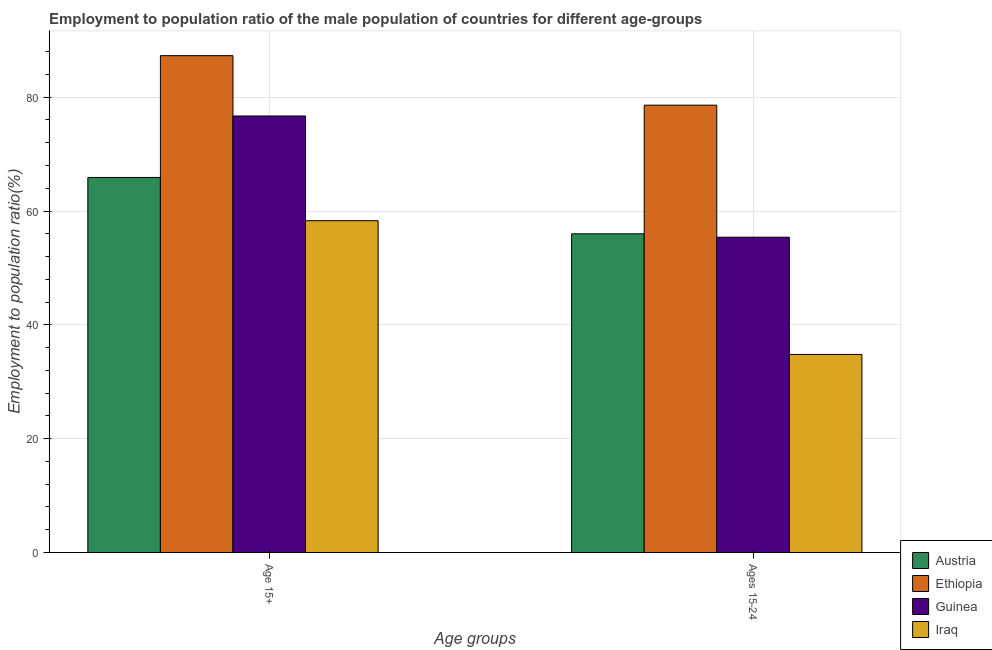How many different coloured bars are there?
Offer a terse response. 4. How many groups of bars are there?
Give a very brief answer. 2. Are the number of bars on each tick of the X-axis equal?
Give a very brief answer. Yes. How many bars are there on the 2nd tick from the right?
Provide a short and direct response. 4. What is the label of the 1st group of bars from the left?
Your answer should be very brief. Age 15+. What is the employment to population ratio(age 15+) in Ethiopia?
Your response must be concise. 87.3. Across all countries, what is the maximum employment to population ratio(age 15+)?
Provide a succinct answer. 87.3. Across all countries, what is the minimum employment to population ratio(age 15-24)?
Offer a very short reply. 34.8. In which country was the employment to population ratio(age 15-24) maximum?
Make the answer very short. Ethiopia. In which country was the employment to population ratio(age 15-24) minimum?
Provide a short and direct response. Iraq. What is the total employment to population ratio(age 15+) in the graph?
Provide a short and direct response. 288.2. What is the difference between the employment to population ratio(age 15+) in Guinea and that in Austria?
Your answer should be very brief. 10.8. What is the difference between the employment to population ratio(age 15+) in Austria and the employment to population ratio(age 15-24) in Ethiopia?
Provide a succinct answer. -12.7. What is the average employment to population ratio(age 15-24) per country?
Give a very brief answer. 56.2. What is the difference between the employment to population ratio(age 15-24) and employment to population ratio(age 15+) in Austria?
Keep it short and to the point. -9.9. In how many countries, is the employment to population ratio(age 15+) greater than 4 %?
Give a very brief answer. 4. What is the ratio of the employment to population ratio(age 15-24) in Ethiopia to that in Austria?
Your answer should be compact. 1.4. Is the employment to population ratio(age 15-24) in Iraq less than that in Austria?
Your response must be concise. Yes. What does the 3rd bar from the left in Ages 15-24 represents?
Offer a very short reply. Guinea. What does the 2nd bar from the right in Ages 15-24 represents?
Provide a short and direct response. Guinea. Are all the bars in the graph horizontal?
Offer a very short reply. No. Are the values on the major ticks of Y-axis written in scientific E-notation?
Provide a succinct answer. No. Does the graph contain any zero values?
Provide a succinct answer. No. Does the graph contain grids?
Keep it short and to the point. Yes. Where does the legend appear in the graph?
Make the answer very short. Bottom right. How many legend labels are there?
Keep it short and to the point. 4. What is the title of the graph?
Give a very brief answer. Employment to population ratio of the male population of countries for different age-groups. What is the label or title of the X-axis?
Offer a very short reply. Age groups. What is the Employment to population ratio(%) in Austria in Age 15+?
Ensure brevity in your answer.  65.9. What is the Employment to population ratio(%) of Ethiopia in Age 15+?
Your answer should be compact. 87.3. What is the Employment to population ratio(%) in Guinea in Age 15+?
Provide a succinct answer. 76.7. What is the Employment to population ratio(%) in Iraq in Age 15+?
Provide a succinct answer. 58.3. What is the Employment to population ratio(%) of Ethiopia in Ages 15-24?
Give a very brief answer. 78.6. What is the Employment to population ratio(%) of Guinea in Ages 15-24?
Your answer should be compact. 55.4. What is the Employment to population ratio(%) of Iraq in Ages 15-24?
Provide a succinct answer. 34.8. Across all Age groups, what is the maximum Employment to population ratio(%) of Austria?
Provide a succinct answer. 65.9. Across all Age groups, what is the maximum Employment to population ratio(%) in Ethiopia?
Ensure brevity in your answer.  87.3. Across all Age groups, what is the maximum Employment to population ratio(%) in Guinea?
Keep it short and to the point. 76.7. Across all Age groups, what is the maximum Employment to population ratio(%) in Iraq?
Ensure brevity in your answer.  58.3. Across all Age groups, what is the minimum Employment to population ratio(%) of Austria?
Make the answer very short. 56. Across all Age groups, what is the minimum Employment to population ratio(%) of Ethiopia?
Give a very brief answer. 78.6. Across all Age groups, what is the minimum Employment to population ratio(%) in Guinea?
Provide a succinct answer. 55.4. Across all Age groups, what is the minimum Employment to population ratio(%) in Iraq?
Offer a terse response. 34.8. What is the total Employment to population ratio(%) of Austria in the graph?
Keep it short and to the point. 121.9. What is the total Employment to population ratio(%) in Ethiopia in the graph?
Provide a short and direct response. 165.9. What is the total Employment to population ratio(%) of Guinea in the graph?
Your answer should be compact. 132.1. What is the total Employment to population ratio(%) in Iraq in the graph?
Your answer should be very brief. 93.1. What is the difference between the Employment to population ratio(%) of Austria in Age 15+ and that in Ages 15-24?
Offer a terse response. 9.9. What is the difference between the Employment to population ratio(%) of Guinea in Age 15+ and that in Ages 15-24?
Offer a very short reply. 21.3. What is the difference between the Employment to population ratio(%) in Iraq in Age 15+ and that in Ages 15-24?
Provide a succinct answer. 23.5. What is the difference between the Employment to population ratio(%) in Austria in Age 15+ and the Employment to population ratio(%) in Iraq in Ages 15-24?
Make the answer very short. 31.1. What is the difference between the Employment to population ratio(%) of Ethiopia in Age 15+ and the Employment to population ratio(%) of Guinea in Ages 15-24?
Make the answer very short. 31.9. What is the difference between the Employment to population ratio(%) of Ethiopia in Age 15+ and the Employment to population ratio(%) of Iraq in Ages 15-24?
Make the answer very short. 52.5. What is the difference between the Employment to population ratio(%) of Guinea in Age 15+ and the Employment to population ratio(%) of Iraq in Ages 15-24?
Provide a succinct answer. 41.9. What is the average Employment to population ratio(%) in Austria per Age groups?
Your response must be concise. 60.95. What is the average Employment to population ratio(%) of Ethiopia per Age groups?
Your answer should be very brief. 82.95. What is the average Employment to population ratio(%) in Guinea per Age groups?
Your response must be concise. 66.05. What is the average Employment to population ratio(%) in Iraq per Age groups?
Your answer should be compact. 46.55. What is the difference between the Employment to population ratio(%) in Austria and Employment to population ratio(%) in Ethiopia in Age 15+?
Ensure brevity in your answer.  -21.4. What is the difference between the Employment to population ratio(%) of Guinea and Employment to population ratio(%) of Iraq in Age 15+?
Your answer should be very brief. 18.4. What is the difference between the Employment to population ratio(%) of Austria and Employment to population ratio(%) of Ethiopia in Ages 15-24?
Offer a terse response. -22.6. What is the difference between the Employment to population ratio(%) of Austria and Employment to population ratio(%) of Iraq in Ages 15-24?
Offer a terse response. 21.2. What is the difference between the Employment to population ratio(%) in Ethiopia and Employment to population ratio(%) in Guinea in Ages 15-24?
Your answer should be very brief. 23.2. What is the difference between the Employment to population ratio(%) in Ethiopia and Employment to population ratio(%) in Iraq in Ages 15-24?
Your response must be concise. 43.8. What is the difference between the Employment to population ratio(%) in Guinea and Employment to population ratio(%) in Iraq in Ages 15-24?
Provide a short and direct response. 20.6. What is the ratio of the Employment to population ratio(%) of Austria in Age 15+ to that in Ages 15-24?
Offer a very short reply. 1.18. What is the ratio of the Employment to population ratio(%) of Ethiopia in Age 15+ to that in Ages 15-24?
Make the answer very short. 1.11. What is the ratio of the Employment to population ratio(%) of Guinea in Age 15+ to that in Ages 15-24?
Your answer should be compact. 1.38. What is the ratio of the Employment to population ratio(%) of Iraq in Age 15+ to that in Ages 15-24?
Ensure brevity in your answer.  1.68. What is the difference between the highest and the second highest Employment to population ratio(%) in Ethiopia?
Provide a short and direct response. 8.7. What is the difference between the highest and the second highest Employment to population ratio(%) of Guinea?
Your answer should be compact. 21.3. What is the difference between the highest and the second highest Employment to population ratio(%) of Iraq?
Ensure brevity in your answer.  23.5. What is the difference between the highest and the lowest Employment to population ratio(%) of Ethiopia?
Provide a succinct answer. 8.7. What is the difference between the highest and the lowest Employment to population ratio(%) in Guinea?
Give a very brief answer. 21.3. 